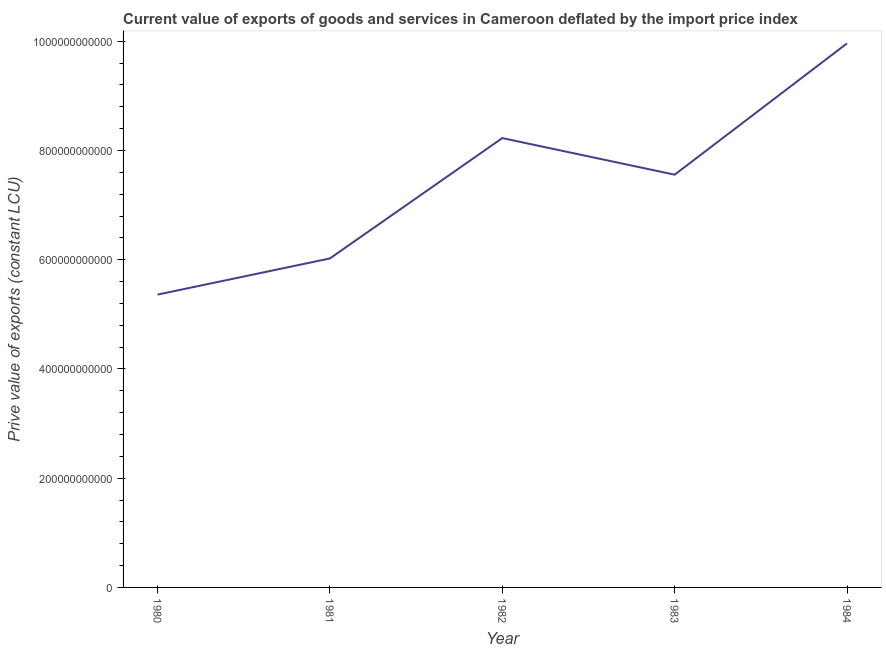What is the price value of exports in 1982?
Your answer should be very brief. 8.23e+11. Across all years, what is the maximum price value of exports?
Ensure brevity in your answer.  9.96e+11. Across all years, what is the minimum price value of exports?
Your answer should be very brief. 5.36e+11. In which year was the price value of exports maximum?
Give a very brief answer. 1984. What is the sum of the price value of exports?
Provide a short and direct response. 3.71e+12. What is the difference between the price value of exports in 1981 and 1983?
Your response must be concise. -1.53e+11. What is the average price value of exports per year?
Offer a very short reply. 7.43e+11. What is the median price value of exports?
Offer a terse response. 7.56e+11. Do a majority of the years between 1980 and 1984 (inclusive) have price value of exports greater than 760000000000 LCU?
Offer a terse response. No. What is the ratio of the price value of exports in 1981 to that in 1984?
Offer a very short reply. 0.6. Is the difference between the price value of exports in 1980 and 1983 greater than the difference between any two years?
Ensure brevity in your answer.  No. What is the difference between the highest and the second highest price value of exports?
Your answer should be very brief. 1.73e+11. Is the sum of the price value of exports in 1983 and 1984 greater than the maximum price value of exports across all years?
Provide a short and direct response. Yes. What is the difference between the highest and the lowest price value of exports?
Offer a terse response. 4.60e+11. Does the price value of exports monotonically increase over the years?
Your answer should be compact. No. What is the difference between two consecutive major ticks on the Y-axis?
Your answer should be compact. 2.00e+11. Does the graph contain grids?
Your response must be concise. No. What is the title of the graph?
Provide a succinct answer. Current value of exports of goods and services in Cameroon deflated by the import price index. What is the label or title of the X-axis?
Give a very brief answer. Year. What is the label or title of the Y-axis?
Ensure brevity in your answer.  Prive value of exports (constant LCU). What is the Prive value of exports (constant LCU) of 1980?
Offer a terse response. 5.36e+11. What is the Prive value of exports (constant LCU) of 1981?
Ensure brevity in your answer.  6.02e+11. What is the Prive value of exports (constant LCU) of 1982?
Your answer should be compact. 8.23e+11. What is the Prive value of exports (constant LCU) of 1983?
Ensure brevity in your answer.  7.56e+11. What is the Prive value of exports (constant LCU) in 1984?
Ensure brevity in your answer.  9.96e+11. What is the difference between the Prive value of exports (constant LCU) in 1980 and 1981?
Give a very brief answer. -6.62e+1. What is the difference between the Prive value of exports (constant LCU) in 1980 and 1982?
Provide a succinct answer. -2.87e+11. What is the difference between the Prive value of exports (constant LCU) in 1980 and 1983?
Provide a succinct answer. -2.20e+11. What is the difference between the Prive value of exports (constant LCU) in 1980 and 1984?
Keep it short and to the point. -4.60e+11. What is the difference between the Prive value of exports (constant LCU) in 1981 and 1982?
Offer a terse response. -2.20e+11. What is the difference between the Prive value of exports (constant LCU) in 1981 and 1983?
Provide a succinct answer. -1.53e+11. What is the difference between the Prive value of exports (constant LCU) in 1981 and 1984?
Keep it short and to the point. -3.94e+11. What is the difference between the Prive value of exports (constant LCU) in 1982 and 1983?
Your answer should be compact. 6.70e+1. What is the difference between the Prive value of exports (constant LCU) in 1982 and 1984?
Provide a succinct answer. -1.73e+11. What is the difference between the Prive value of exports (constant LCU) in 1983 and 1984?
Your response must be concise. -2.40e+11. What is the ratio of the Prive value of exports (constant LCU) in 1980 to that in 1981?
Offer a very short reply. 0.89. What is the ratio of the Prive value of exports (constant LCU) in 1980 to that in 1982?
Your answer should be very brief. 0.65. What is the ratio of the Prive value of exports (constant LCU) in 1980 to that in 1983?
Ensure brevity in your answer.  0.71. What is the ratio of the Prive value of exports (constant LCU) in 1980 to that in 1984?
Provide a short and direct response. 0.54. What is the ratio of the Prive value of exports (constant LCU) in 1981 to that in 1982?
Your answer should be compact. 0.73. What is the ratio of the Prive value of exports (constant LCU) in 1981 to that in 1983?
Your response must be concise. 0.8. What is the ratio of the Prive value of exports (constant LCU) in 1981 to that in 1984?
Keep it short and to the point. 0.6. What is the ratio of the Prive value of exports (constant LCU) in 1982 to that in 1983?
Your answer should be very brief. 1.09. What is the ratio of the Prive value of exports (constant LCU) in 1982 to that in 1984?
Offer a very short reply. 0.83. What is the ratio of the Prive value of exports (constant LCU) in 1983 to that in 1984?
Ensure brevity in your answer.  0.76. 